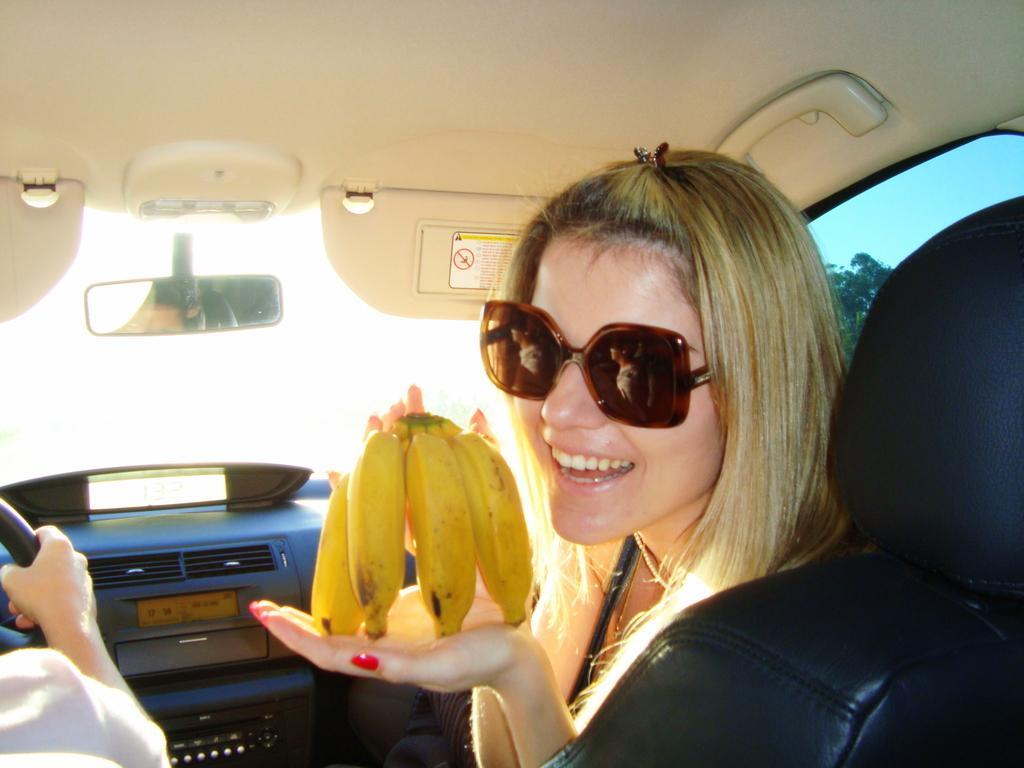How would you summarize this image in a sentence or two? In this picture there is a woman, wearing a spectacles, sitting in a seat of a car. She is showing bananas to the camera. Beside her, there is another person driving a car. In the background there are some trees and sky here. 